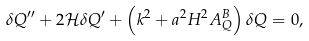<formula> <loc_0><loc_0><loc_500><loc_500>\delta Q ^ { \prime \prime } + 2 \mathcal { H } \delta Q ^ { \prime } + \left ( k ^ { 2 } + a ^ { 2 } H ^ { 2 } A _ { Q } ^ { B } \right ) \delta Q = 0 ,</formula> 